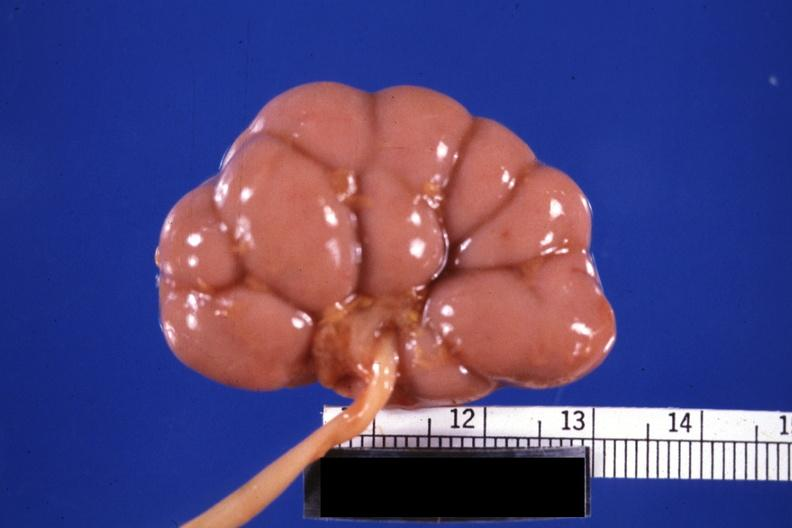does this image show fixed tissue good example small kidney?
Answer the question using a single word or phrase. Yes 